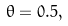Convert formula to latex. <formula><loc_0><loc_0><loc_500><loc_500>\theta = 0 . 5 ,</formula> 